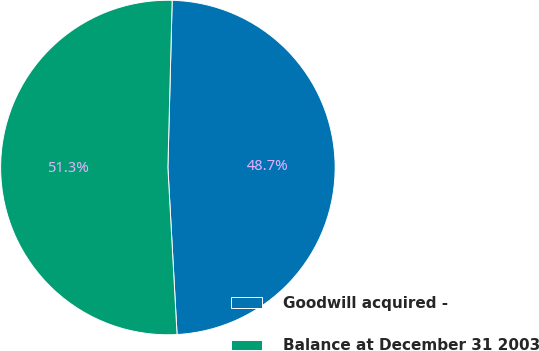Convert chart. <chart><loc_0><loc_0><loc_500><loc_500><pie_chart><fcel>Goodwill acquired -<fcel>Balance at December 31 2003<nl><fcel>48.72%<fcel>51.28%<nl></chart> 